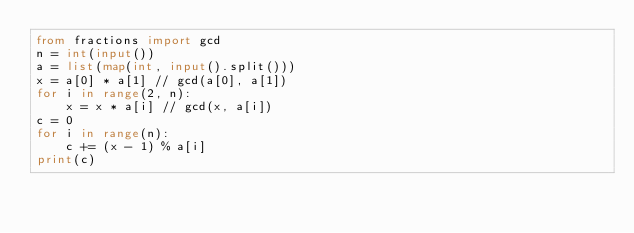<code> <loc_0><loc_0><loc_500><loc_500><_Python_>from fractions import gcd
n = int(input())
a = list(map(int, input().split()))
x = a[0] * a[1] // gcd(a[0], a[1])
for i in range(2, n):
    x = x * a[i] // gcd(x, a[i])
c = 0
for i in range(n):
    c += (x - 1) % a[i]
print(c)
</code> 